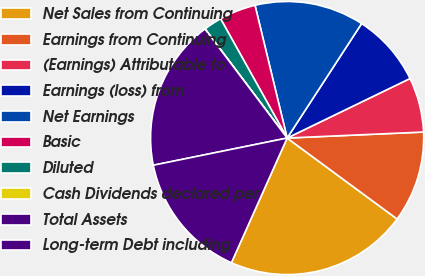<chart> <loc_0><loc_0><loc_500><loc_500><pie_chart><fcel>Net Sales from Continuing<fcel>Earnings from Continuing<fcel>(Earnings) Attributable to<fcel>Earnings (loss) from<fcel>Net Earnings<fcel>Basic<fcel>Diluted<fcel>Cash Dividends declared per<fcel>Total Assets<fcel>Long-term Debt including<nl><fcel>21.59%<fcel>10.8%<fcel>6.48%<fcel>8.64%<fcel>12.96%<fcel>4.32%<fcel>2.17%<fcel>0.01%<fcel>17.91%<fcel>15.12%<nl></chart> 